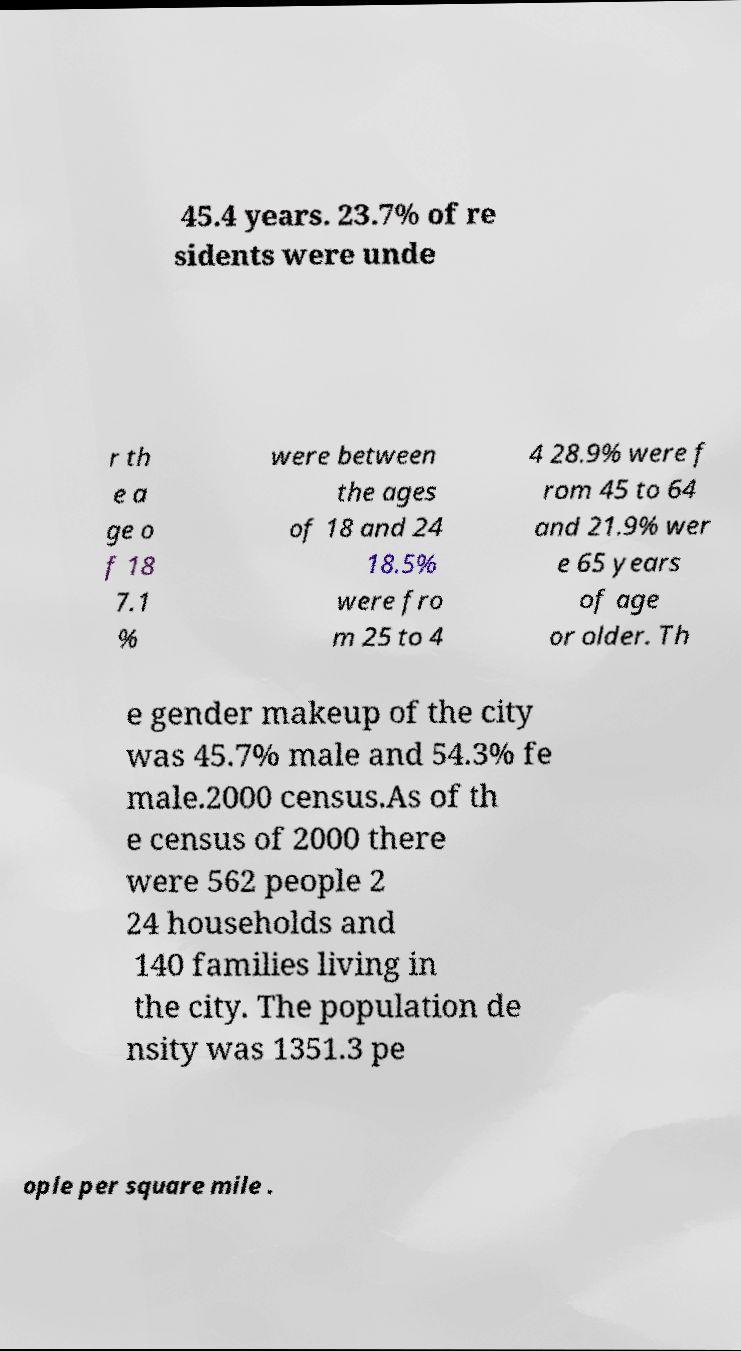Can you read and provide the text displayed in the image?This photo seems to have some interesting text. Can you extract and type it out for me? 45.4 years. 23.7% of re sidents were unde r th e a ge o f 18 7.1 % were between the ages of 18 and 24 18.5% were fro m 25 to 4 4 28.9% were f rom 45 to 64 and 21.9% wer e 65 years of age or older. Th e gender makeup of the city was 45.7% male and 54.3% fe male.2000 census.As of th e census of 2000 there were 562 people 2 24 households and 140 families living in the city. The population de nsity was 1351.3 pe ople per square mile . 